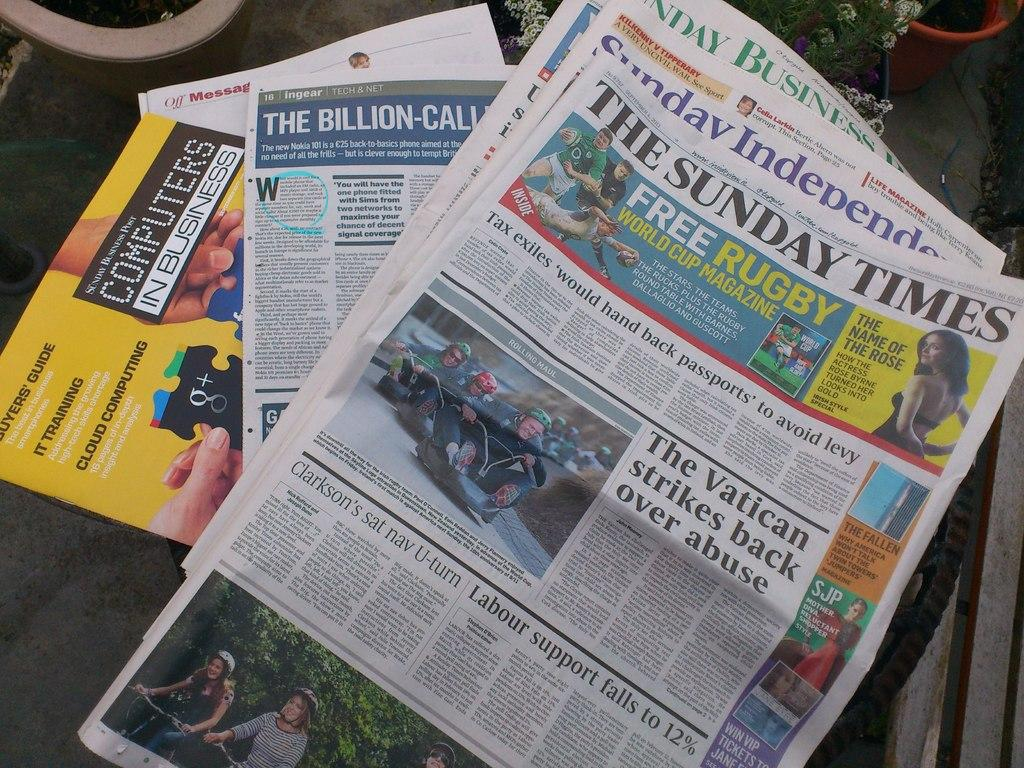<image>
Offer a succinct explanation of the picture presented. A newspaper for The Sunday Times sitting on a stack of other papers. 